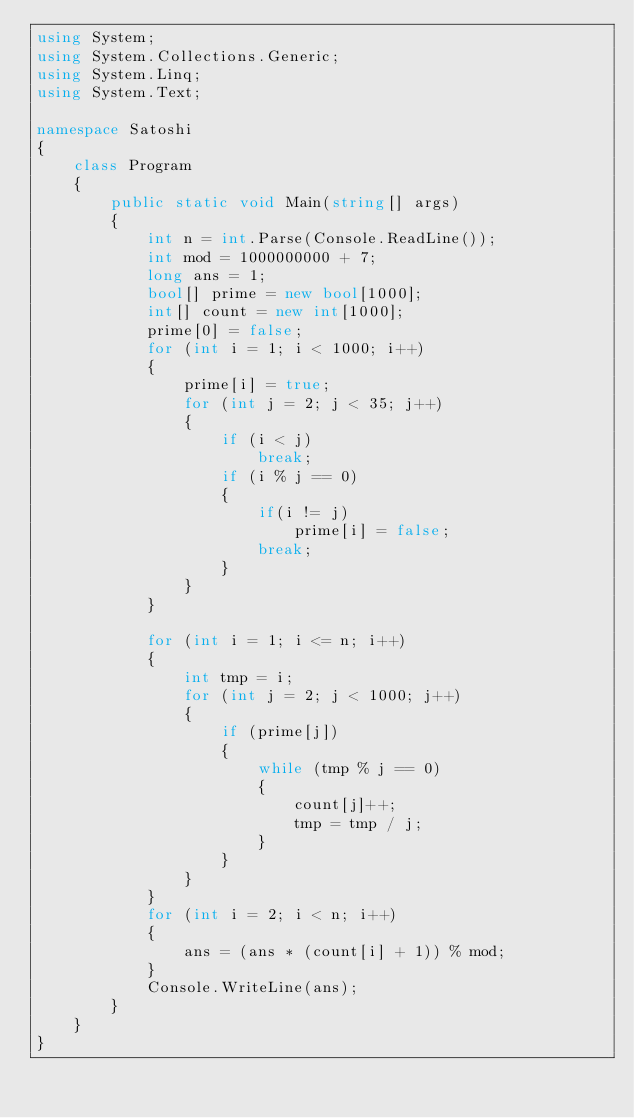<code> <loc_0><loc_0><loc_500><loc_500><_C#_>using System;
using System.Collections.Generic;
using System.Linq;
using System.Text;

namespace Satoshi
{
	class Program
	{
		public static void Main(string[] args)
		{
			int n = int.Parse(Console.ReadLine());
			int mod = 1000000000 + 7;
			long ans = 1;
			bool[] prime = new bool[1000];
			int[] count = new int[1000];
			prime[0] = false;
			for (int i = 1; i < 1000; i++)
			{
				prime[i] = true;
				for (int j = 2; j < 35; j++)
				{
					if (i < j)
						break;
					if (i % j == 0)
					{
						if(i != j)
							prime[i] = false;
						break;
					}
				}
			}

			for (int i = 1; i <= n; i++)
			{
				int tmp = i;
				for (int j = 2; j < 1000; j++)
				{
					if (prime[j])
					{
						while (tmp % j == 0)
						{
							count[j]++;
							tmp = tmp / j;
						}
					}
				}
			}
			for (int i = 2; i < n; i++)
			{
				ans = (ans * (count[i] + 1)) % mod;
			}
			Console.WriteLine(ans);
		}
	}
}</code> 